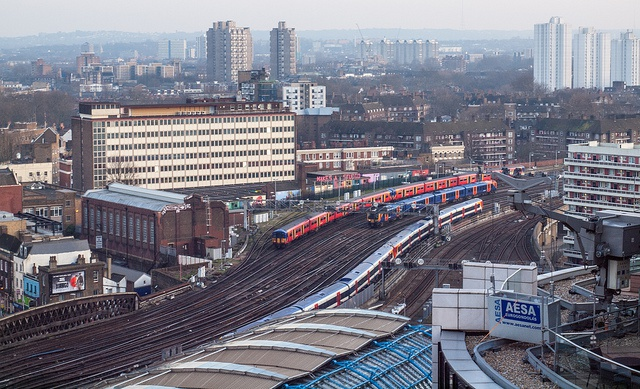Describe the objects in this image and their specific colors. I can see train in lightgray, darkgray, gray, and navy tones, train in lightgray, salmon, gray, black, and navy tones, and train in lightgray, navy, gray, and black tones in this image. 